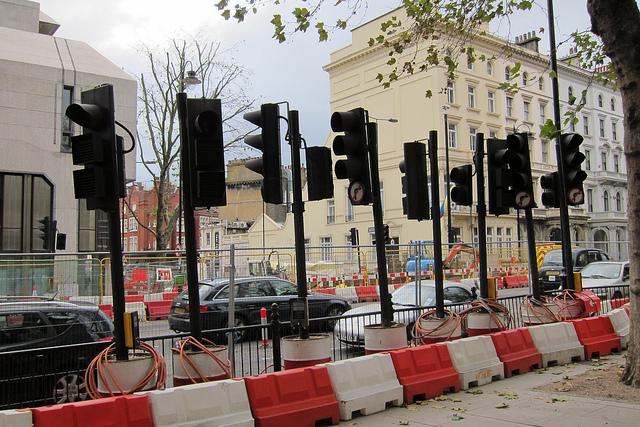How many traffic lights are by the fence?
Give a very brief answer. 8. What city is this?
Short answer required. New york. What color is the car?
Give a very brief answer. Black. Is this a parking place?
Keep it brief. No. Is this a city street?
Write a very short answer. Yes. 